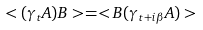Convert formula to latex. <formula><loc_0><loc_0><loc_500><loc_500>< ( \gamma _ { t } A ) B > = < B ( \gamma _ { t + i \beta } A ) ></formula> 